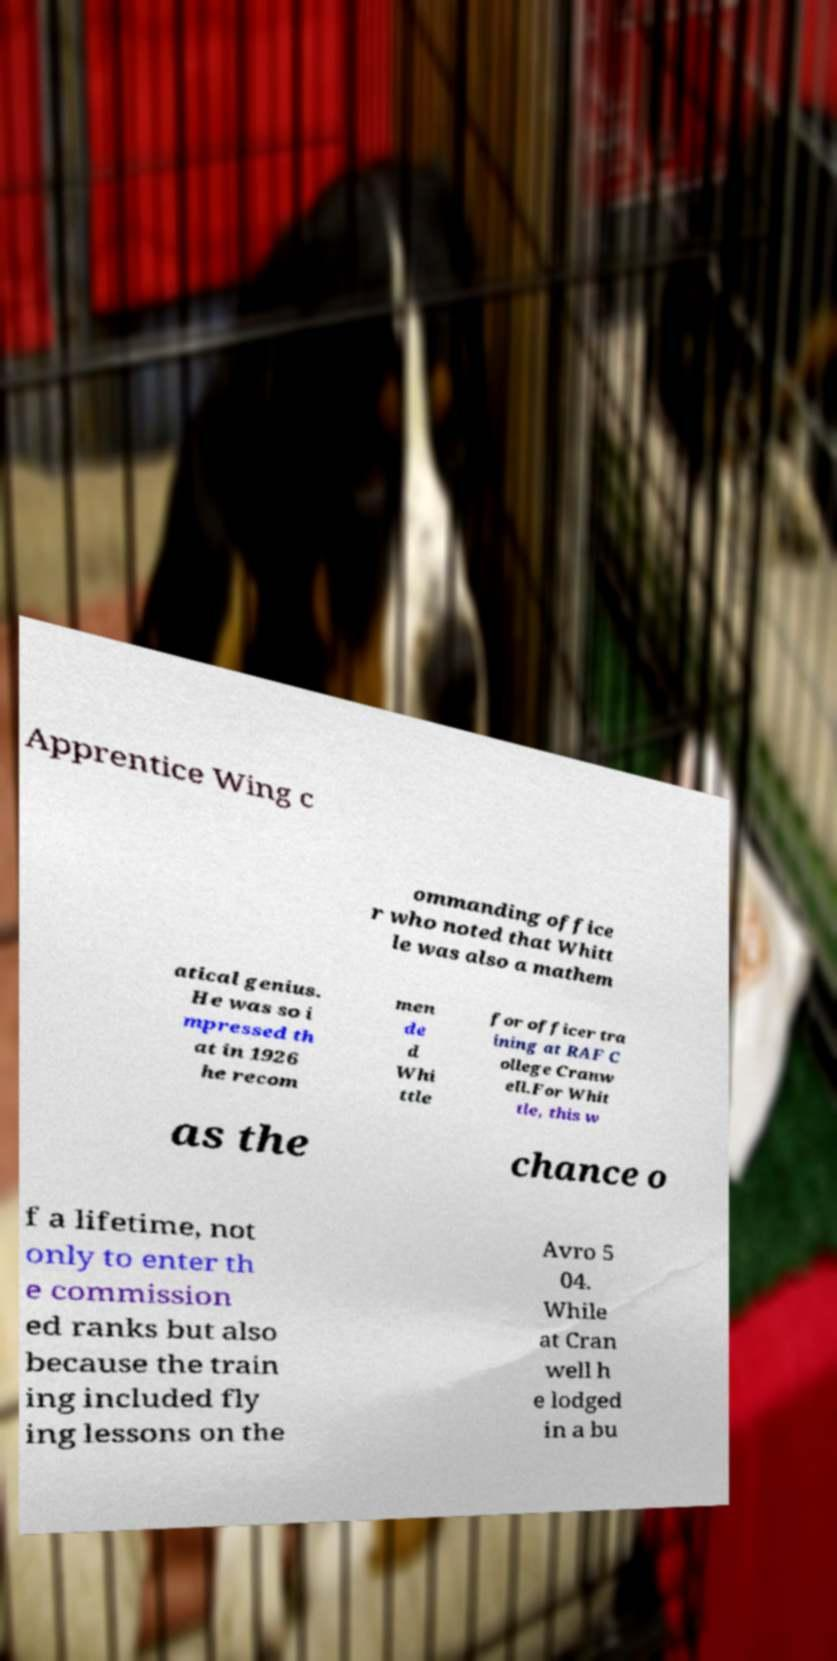For documentation purposes, I need the text within this image transcribed. Could you provide that? Apprentice Wing c ommanding office r who noted that Whitt le was also a mathem atical genius. He was so i mpressed th at in 1926 he recom men de d Whi ttle for officer tra ining at RAF C ollege Cranw ell.For Whit tle, this w as the chance o f a lifetime, not only to enter th e commission ed ranks but also because the train ing included fly ing lessons on the Avro 5 04. While at Cran well h e lodged in a bu 